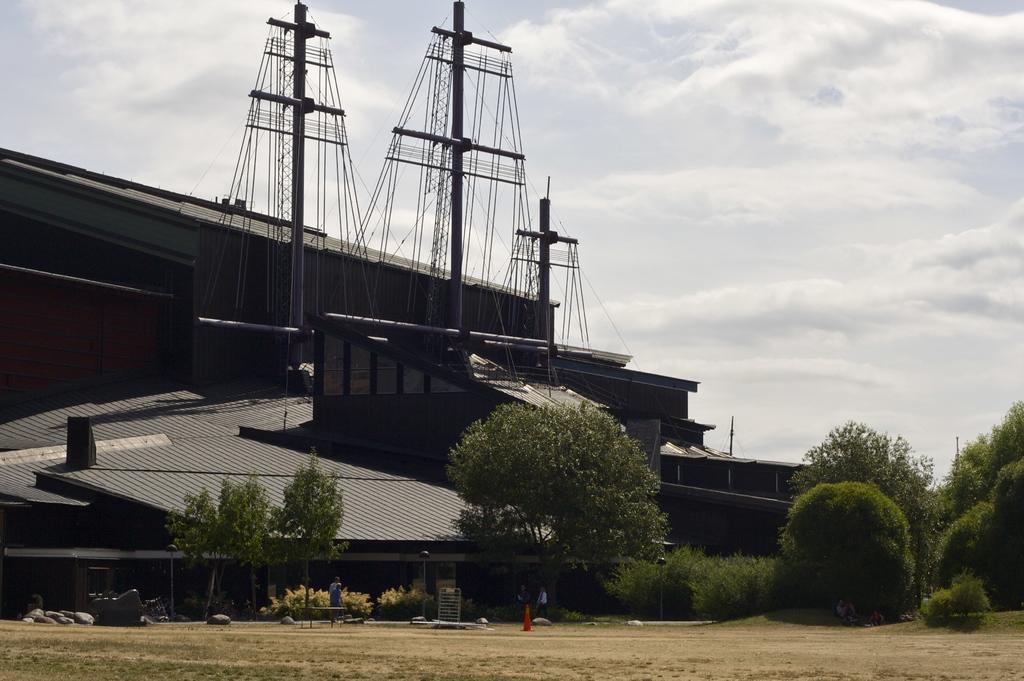In one or two sentences, can you explain what this image depicts? In this image, we can see a few houses. We can see some poles with wires. We can see the ground. We can see some objects like rocks. There are a few people. We can see some plants and trees. We can see the sky with clouds. 